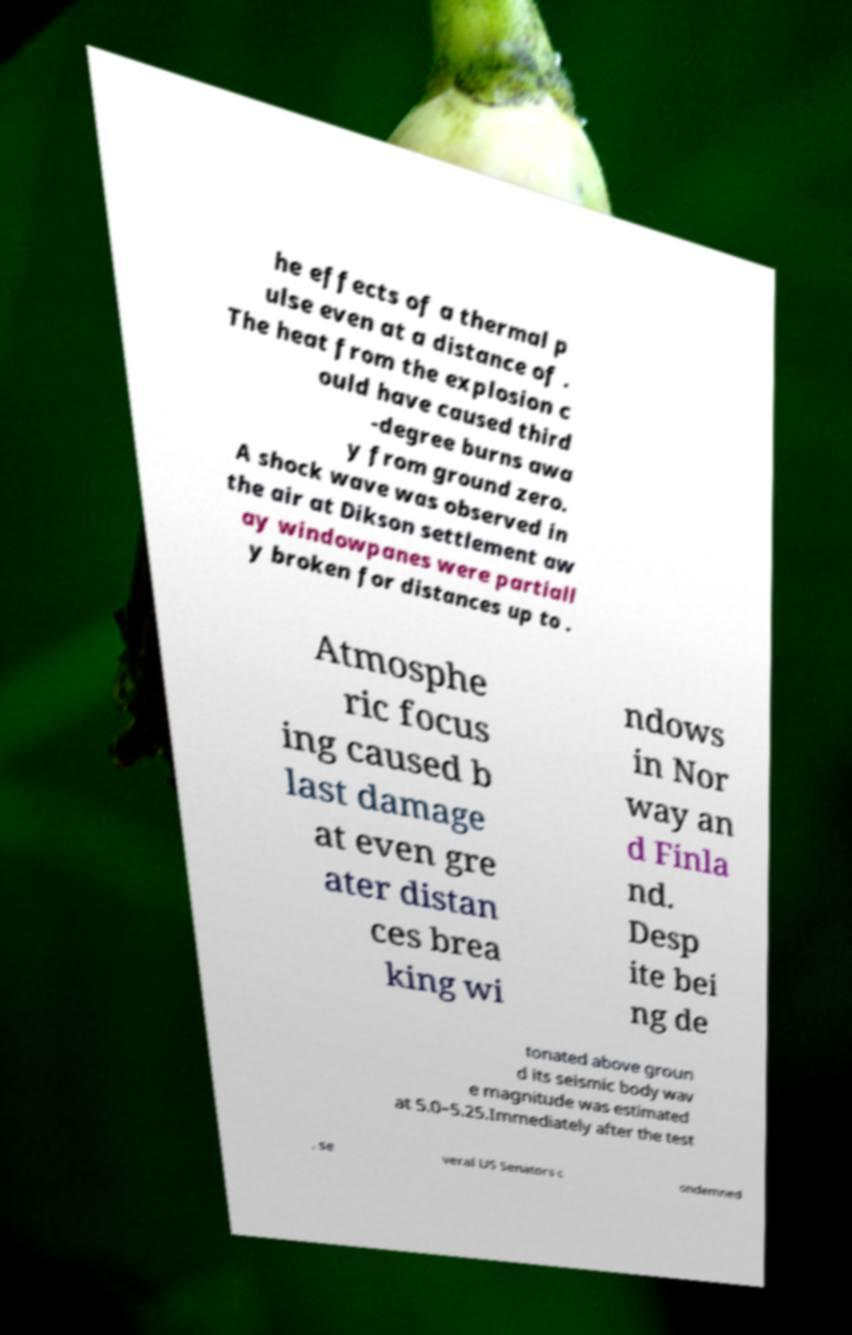Please read and relay the text visible in this image. What does it say? he effects of a thermal p ulse even at a distance of . The heat from the explosion c ould have caused third -degree burns awa y from ground zero. A shock wave was observed in the air at Dikson settlement aw ay windowpanes were partiall y broken for distances up to . Atmosphe ric focus ing caused b last damage at even gre ater distan ces brea king wi ndows in Nor way an d Finla nd. Desp ite bei ng de tonated above groun d its seismic body wav e magnitude was estimated at 5.0–5.25.Immediately after the test , se veral US Senators c ondemned 